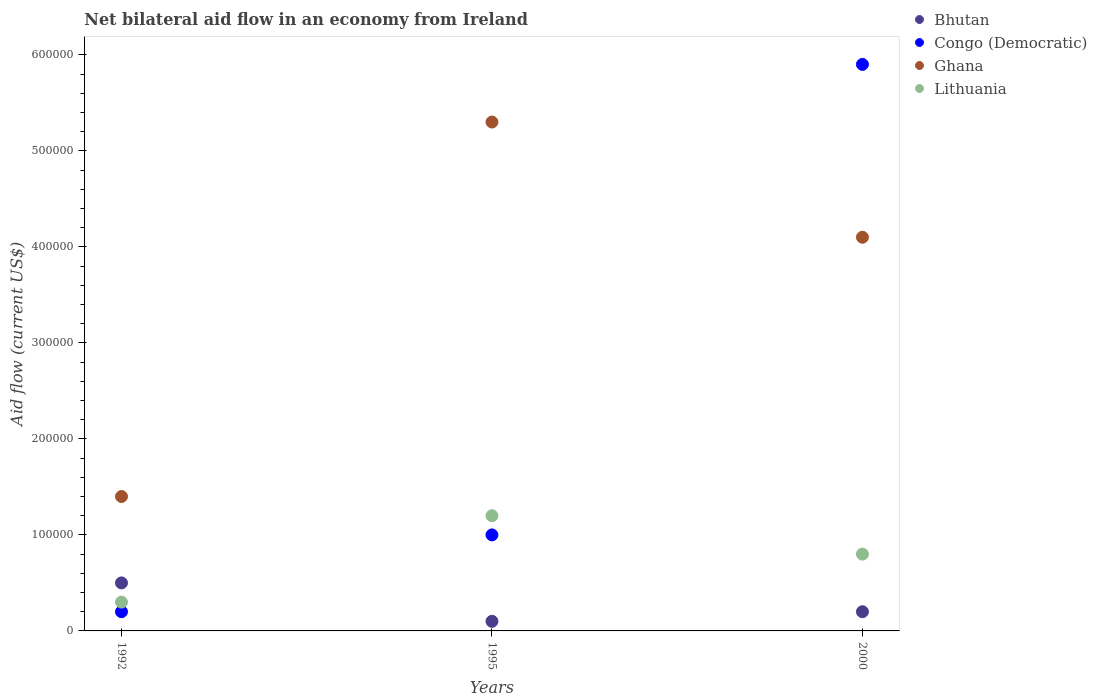What is the net bilateral aid flow in Bhutan in 2000?
Provide a short and direct response. 2.00e+04. Across all years, what is the maximum net bilateral aid flow in Lithuania?
Keep it short and to the point. 1.20e+05. What is the total net bilateral aid flow in Lithuania in the graph?
Your answer should be compact. 2.30e+05. What is the difference between the net bilateral aid flow in Congo (Democratic) in 1992 and the net bilateral aid flow in Ghana in 2000?
Provide a succinct answer. -3.90e+05. What is the average net bilateral aid flow in Lithuania per year?
Offer a terse response. 7.67e+04. What is the ratio of the net bilateral aid flow in Ghana in 1995 to that in 2000?
Your answer should be compact. 1.29. Is the difference between the net bilateral aid flow in Congo (Democratic) in 1992 and 1995 greater than the difference between the net bilateral aid flow in Ghana in 1992 and 1995?
Provide a succinct answer. Yes. What is the difference between the highest and the lowest net bilateral aid flow in Lithuania?
Provide a succinct answer. 9.00e+04. Is it the case that in every year, the sum of the net bilateral aid flow in Bhutan and net bilateral aid flow in Lithuania  is greater than the sum of net bilateral aid flow in Ghana and net bilateral aid flow in Congo (Democratic)?
Provide a succinct answer. No. Is it the case that in every year, the sum of the net bilateral aid flow in Bhutan and net bilateral aid flow in Ghana  is greater than the net bilateral aid flow in Lithuania?
Make the answer very short. Yes. Does the net bilateral aid flow in Ghana monotonically increase over the years?
Ensure brevity in your answer.  No. Is the net bilateral aid flow in Ghana strictly greater than the net bilateral aid flow in Lithuania over the years?
Make the answer very short. Yes. Is the net bilateral aid flow in Lithuania strictly less than the net bilateral aid flow in Ghana over the years?
Your response must be concise. Yes. How many dotlines are there?
Keep it short and to the point. 4. Does the graph contain any zero values?
Ensure brevity in your answer.  No. How are the legend labels stacked?
Make the answer very short. Vertical. What is the title of the graph?
Ensure brevity in your answer.  Net bilateral aid flow in an economy from Ireland. Does "Solomon Islands" appear as one of the legend labels in the graph?
Give a very brief answer. No. What is the label or title of the Y-axis?
Your answer should be compact. Aid flow (current US$). What is the Aid flow (current US$) of Bhutan in 1992?
Provide a succinct answer. 5.00e+04. What is the Aid flow (current US$) in Congo (Democratic) in 1992?
Provide a succinct answer. 2.00e+04. What is the Aid flow (current US$) of Lithuania in 1992?
Provide a short and direct response. 3.00e+04. What is the Aid flow (current US$) in Congo (Democratic) in 1995?
Offer a terse response. 1.00e+05. What is the Aid flow (current US$) in Ghana in 1995?
Provide a succinct answer. 5.30e+05. What is the Aid flow (current US$) of Lithuania in 1995?
Provide a short and direct response. 1.20e+05. What is the Aid flow (current US$) in Bhutan in 2000?
Provide a succinct answer. 2.00e+04. What is the Aid flow (current US$) of Congo (Democratic) in 2000?
Your answer should be compact. 5.90e+05. What is the Aid flow (current US$) in Ghana in 2000?
Ensure brevity in your answer.  4.10e+05. Across all years, what is the maximum Aid flow (current US$) in Congo (Democratic)?
Give a very brief answer. 5.90e+05. Across all years, what is the maximum Aid flow (current US$) of Ghana?
Keep it short and to the point. 5.30e+05. Across all years, what is the maximum Aid flow (current US$) in Lithuania?
Make the answer very short. 1.20e+05. Across all years, what is the minimum Aid flow (current US$) in Bhutan?
Ensure brevity in your answer.  10000. What is the total Aid flow (current US$) in Bhutan in the graph?
Give a very brief answer. 8.00e+04. What is the total Aid flow (current US$) in Congo (Democratic) in the graph?
Your answer should be compact. 7.10e+05. What is the total Aid flow (current US$) of Ghana in the graph?
Offer a very short reply. 1.08e+06. What is the difference between the Aid flow (current US$) in Congo (Democratic) in 1992 and that in 1995?
Provide a succinct answer. -8.00e+04. What is the difference between the Aid flow (current US$) in Ghana in 1992 and that in 1995?
Keep it short and to the point. -3.90e+05. What is the difference between the Aid flow (current US$) of Bhutan in 1992 and that in 2000?
Offer a terse response. 3.00e+04. What is the difference between the Aid flow (current US$) in Congo (Democratic) in 1992 and that in 2000?
Offer a very short reply. -5.70e+05. What is the difference between the Aid flow (current US$) in Lithuania in 1992 and that in 2000?
Your answer should be compact. -5.00e+04. What is the difference between the Aid flow (current US$) of Congo (Democratic) in 1995 and that in 2000?
Your response must be concise. -4.90e+05. What is the difference between the Aid flow (current US$) of Bhutan in 1992 and the Aid flow (current US$) of Ghana in 1995?
Your answer should be compact. -4.80e+05. What is the difference between the Aid flow (current US$) in Bhutan in 1992 and the Aid flow (current US$) in Lithuania in 1995?
Provide a succinct answer. -7.00e+04. What is the difference between the Aid flow (current US$) of Congo (Democratic) in 1992 and the Aid flow (current US$) of Ghana in 1995?
Make the answer very short. -5.10e+05. What is the difference between the Aid flow (current US$) in Ghana in 1992 and the Aid flow (current US$) in Lithuania in 1995?
Your answer should be compact. 2.00e+04. What is the difference between the Aid flow (current US$) of Bhutan in 1992 and the Aid flow (current US$) of Congo (Democratic) in 2000?
Your response must be concise. -5.40e+05. What is the difference between the Aid flow (current US$) in Bhutan in 1992 and the Aid flow (current US$) in Ghana in 2000?
Provide a short and direct response. -3.60e+05. What is the difference between the Aid flow (current US$) in Congo (Democratic) in 1992 and the Aid flow (current US$) in Ghana in 2000?
Make the answer very short. -3.90e+05. What is the difference between the Aid flow (current US$) in Congo (Democratic) in 1992 and the Aid flow (current US$) in Lithuania in 2000?
Provide a succinct answer. -6.00e+04. What is the difference between the Aid flow (current US$) in Ghana in 1992 and the Aid flow (current US$) in Lithuania in 2000?
Keep it short and to the point. 6.00e+04. What is the difference between the Aid flow (current US$) of Bhutan in 1995 and the Aid flow (current US$) of Congo (Democratic) in 2000?
Make the answer very short. -5.80e+05. What is the difference between the Aid flow (current US$) of Bhutan in 1995 and the Aid flow (current US$) of Ghana in 2000?
Offer a very short reply. -4.00e+05. What is the difference between the Aid flow (current US$) of Congo (Democratic) in 1995 and the Aid flow (current US$) of Ghana in 2000?
Keep it short and to the point. -3.10e+05. What is the average Aid flow (current US$) in Bhutan per year?
Provide a succinct answer. 2.67e+04. What is the average Aid flow (current US$) of Congo (Democratic) per year?
Make the answer very short. 2.37e+05. What is the average Aid flow (current US$) in Lithuania per year?
Give a very brief answer. 7.67e+04. In the year 1992, what is the difference between the Aid flow (current US$) of Bhutan and Aid flow (current US$) of Congo (Democratic)?
Your answer should be compact. 3.00e+04. In the year 1992, what is the difference between the Aid flow (current US$) in Congo (Democratic) and Aid flow (current US$) in Ghana?
Make the answer very short. -1.20e+05. In the year 1992, what is the difference between the Aid flow (current US$) of Ghana and Aid flow (current US$) of Lithuania?
Ensure brevity in your answer.  1.10e+05. In the year 1995, what is the difference between the Aid flow (current US$) in Bhutan and Aid flow (current US$) in Congo (Democratic)?
Your answer should be very brief. -9.00e+04. In the year 1995, what is the difference between the Aid flow (current US$) of Bhutan and Aid flow (current US$) of Ghana?
Your answer should be compact. -5.20e+05. In the year 1995, what is the difference between the Aid flow (current US$) in Bhutan and Aid flow (current US$) in Lithuania?
Provide a succinct answer. -1.10e+05. In the year 1995, what is the difference between the Aid flow (current US$) in Congo (Democratic) and Aid flow (current US$) in Ghana?
Make the answer very short. -4.30e+05. In the year 1995, what is the difference between the Aid flow (current US$) in Congo (Democratic) and Aid flow (current US$) in Lithuania?
Provide a succinct answer. -2.00e+04. In the year 1995, what is the difference between the Aid flow (current US$) in Ghana and Aid flow (current US$) in Lithuania?
Your answer should be compact. 4.10e+05. In the year 2000, what is the difference between the Aid flow (current US$) of Bhutan and Aid flow (current US$) of Congo (Democratic)?
Your answer should be very brief. -5.70e+05. In the year 2000, what is the difference between the Aid flow (current US$) in Bhutan and Aid flow (current US$) in Ghana?
Ensure brevity in your answer.  -3.90e+05. In the year 2000, what is the difference between the Aid flow (current US$) of Congo (Democratic) and Aid flow (current US$) of Ghana?
Provide a succinct answer. 1.80e+05. In the year 2000, what is the difference between the Aid flow (current US$) in Congo (Democratic) and Aid flow (current US$) in Lithuania?
Provide a succinct answer. 5.10e+05. In the year 2000, what is the difference between the Aid flow (current US$) in Ghana and Aid flow (current US$) in Lithuania?
Your answer should be compact. 3.30e+05. What is the ratio of the Aid flow (current US$) in Congo (Democratic) in 1992 to that in 1995?
Your answer should be very brief. 0.2. What is the ratio of the Aid flow (current US$) in Ghana in 1992 to that in 1995?
Provide a short and direct response. 0.26. What is the ratio of the Aid flow (current US$) of Lithuania in 1992 to that in 1995?
Keep it short and to the point. 0.25. What is the ratio of the Aid flow (current US$) of Bhutan in 1992 to that in 2000?
Provide a succinct answer. 2.5. What is the ratio of the Aid flow (current US$) in Congo (Democratic) in 1992 to that in 2000?
Ensure brevity in your answer.  0.03. What is the ratio of the Aid flow (current US$) in Ghana in 1992 to that in 2000?
Provide a short and direct response. 0.34. What is the ratio of the Aid flow (current US$) of Lithuania in 1992 to that in 2000?
Make the answer very short. 0.38. What is the ratio of the Aid flow (current US$) of Bhutan in 1995 to that in 2000?
Offer a very short reply. 0.5. What is the ratio of the Aid flow (current US$) in Congo (Democratic) in 1995 to that in 2000?
Offer a very short reply. 0.17. What is the ratio of the Aid flow (current US$) in Ghana in 1995 to that in 2000?
Give a very brief answer. 1.29. What is the difference between the highest and the second highest Aid flow (current US$) in Bhutan?
Offer a terse response. 3.00e+04. What is the difference between the highest and the lowest Aid flow (current US$) in Bhutan?
Make the answer very short. 4.00e+04. What is the difference between the highest and the lowest Aid flow (current US$) in Congo (Democratic)?
Provide a short and direct response. 5.70e+05. What is the difference between the highest and the lowest Aid flow (current US$) in Ghana?
Ensure brevity in your answer.  3.90e+05. 